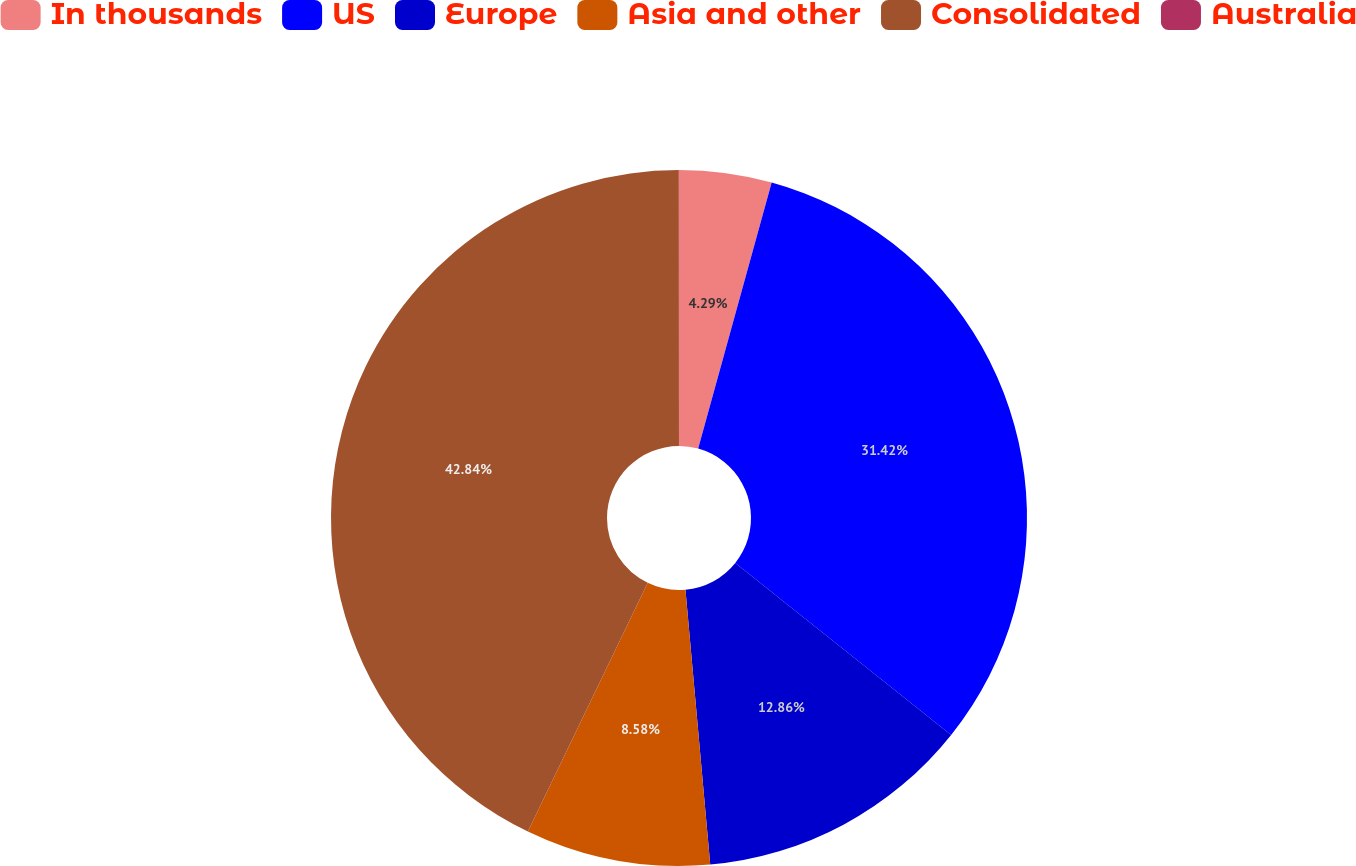Convert chart to OTSL. <chart><loc_0><loc_0><loc_500><loc_500><pie_chart><fcel>In thousands<fcel>US<fcel>Europe<fcel>Asia and other<fcel>Consolidated<fcel>Australia<nl><fcel>4.29%<fcel>31.42%<fcel>12.86%<fcel>8.58%<fcel>42.84%<fcel>0.01%<nl></chart> 